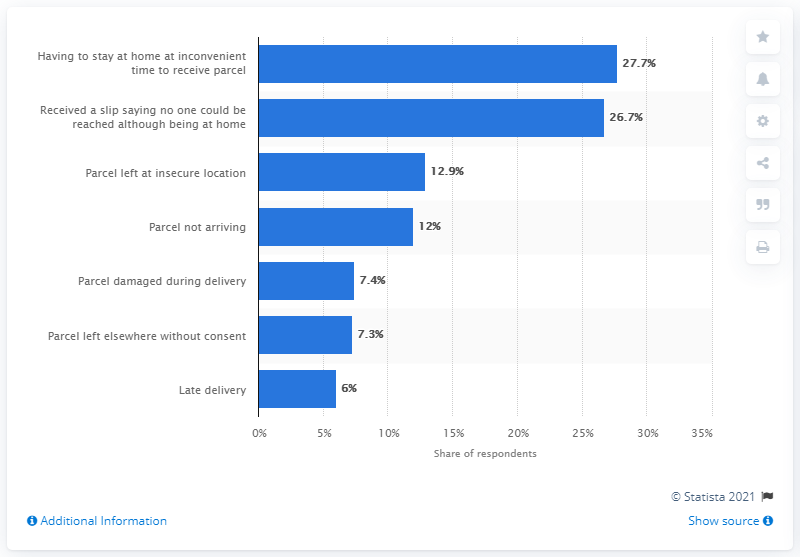Identify some key points in this picture. According to the respondents, 27.7% of them considered the above as the main nuisance. 